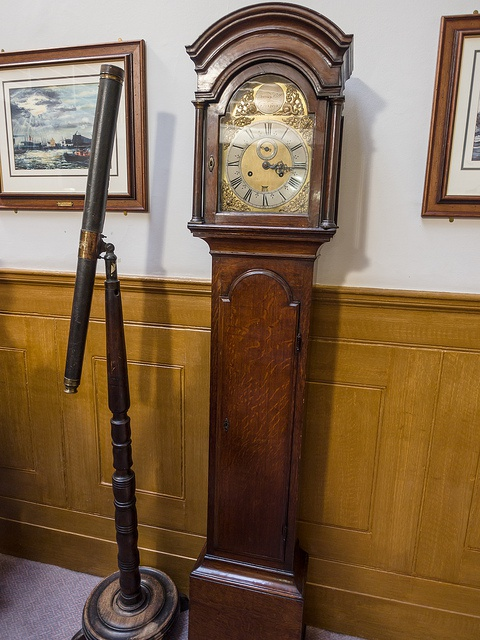Describe the objects in this image and their specific colors. I can see a clock in lightgray, darkgray, and tan tones in this image. 